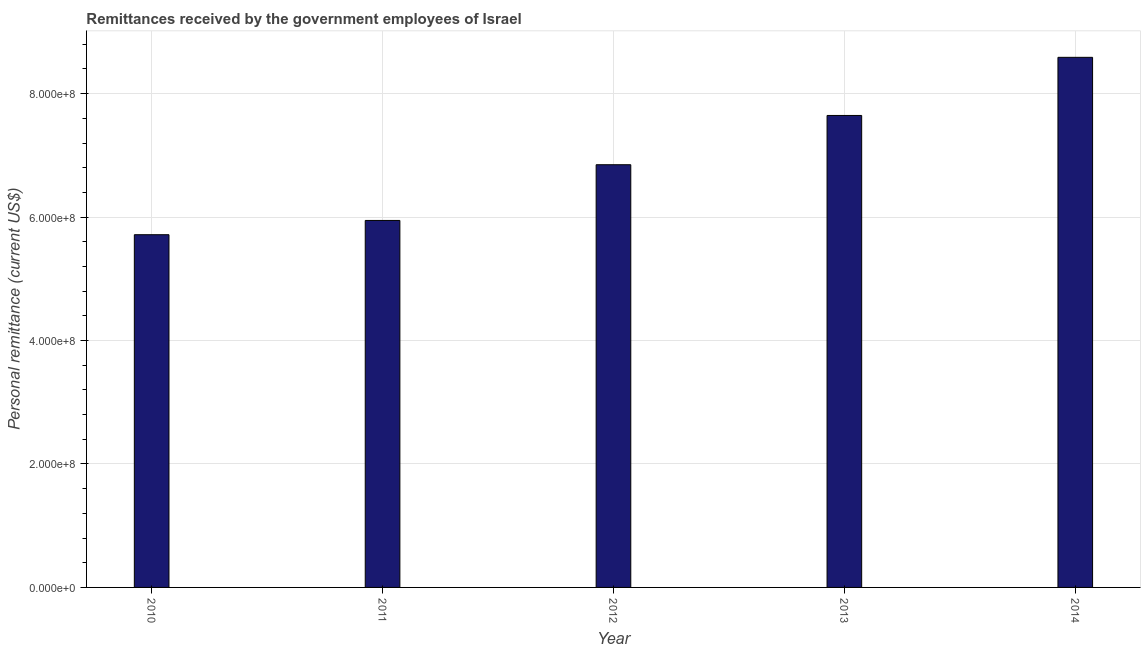Does the graph contain any zero values?
Make the answer very short. No. What is the title of the graph?
Ensure brevity in your answer.  Remittances received by the government employees of Israel. What is the label or title of the X-axis?
Your answer should be compact. Year. What is the label or title of the Y-axis?
Your answer should be very brief. Personal remittance (current US$). What is the personal remittances in 2010?
Make the answer very short. 5.72e+08. Across all years, what is the maximum personal remittances?
Offer a terse response. 8.59e+08. Across all years, what is the minimum personal remittances?
Keep it short and to the point. 5.72e+08. In which year was the personal remittances maximum?
Make the answer very short. 2014. What is the sum of the personal remittances?
Your answer should be very brief. 3.47e+09. What is the difference between the personal remittances in 2011 and 2012?
Give a very brief answer. -9.03e+07. What is the average personal remittances per year?
Provide a short and direct response. 6.95e+08. What is the median personal remittances?
Make the answer very short. 6.85e+08. Do a majority of the years between 2010 and 2012 (inclusive) have personal remittances greater than 240000000 US$?
Ensure brevity in your answer.  Yes. What is the ratio of the personal remittances in 2013 to that in 2014?
Ensure brevity in your answer.  0.89. What is the difference between the highest and the second highest personal remittances?
Make the answer very short. 9.42e+07. What is the difference between the highest and the lowest personal remittances?
Offer a terse response. 2.87e+08. Are all the bars in the graph horizontal?
Make the answer very short. No. Are the values on the major ticks of Y-axis written in scientific E-notation?
Offer a very short reply. Yes. What is the Personal remittance (current US$) of 2010?
Your answer should be compact. 5.72e+08. What is the Personal remittance (current US$) in 2011?
Provide a succinct answer. 5.95e+08. What is the Personal remittance (current US$) of 2012?
Make the answer very short. 6.85e+08. What is the Personal remittance (current US$) in 2013?
Provide a succinct answer. 7.65e+08. What is the Personal remittance (current US$) in 2014?
Provide a succinct answer. 8.59e+08. What is the difference between the Personal remittance (current US$) in 2010 and 2011?
Give a very brief answer. -2.31e+07. What is the difference between the Personal remittance (current US$) in 2010 and 2012?
Keep it short and to the point. -1.13e+08. What is the difference between the Personal remittance (current US$) in 2010 and 2013?
Keep it short and to the point. -1.93e+08. What is the difference between the Personal remittance (current US$) in 2010 and 2014?
Make the answer very short. -2.87e+08. What is the difference between the Personal remittance (current US$) in 2011 and 2012?
Provide a succinct answer. -9.03e+07. What is the difference between the Personal remittance (current US$) in 2011 and 2013?
Give a very brief answer. -1.70e+08. What is the difference between the Personal remittance (current US$) in 2011 and 2014?
Keep it short and to the point. -2.64e+08. What is the difference between the Personal remittance (current US$) in 2012 and 2013?
Keep it short and to the point. -7.98e+07. What is the difference between the Personal remittance (current US$) in 2012 and 2014?
Your answer should be very brief. -1.74e+08. What is the difference between the Personal remittance (current US$) in 2013 and 2014?
Your response must be concise. -9.42e+07. What is the ratio of the Personal remittance (current US$) in 2010 to that in 2011?
Your response must be concise. 0.96. What is the ratio of the Personal remittance (current US$) in 2010 to that in 2012?
Provide a short and direct response. 0.83. What is the ratio of the Personal remittance (current US$) in 2010 to that in 2013?
Your answer should be very brief. 0.75. What is the ratio of the Personal remittance (current US$) in 2010 to that in 2014?
Give a very brief answer. 0.67. What is the ratio of the Personal remittance (current US$) in 2011 to that in 2012?
Offer a terse response. 0.87. What is the ratio of the Personal remittance (current US$) in 2011 to that in 2013?
Give a very brief answer. 0.78. What is the ratio of the Personal remittance (current US$) in 2011 to that in 2014?
Provide a succinct answer. 0.69. What is the ratio of the Personal remittance (current US$) in 2012 to that in 2013?
Offer a terse response. 0.9. What is the ratio of the Personal remittance (current US$) in 2012 to that in 2014?
Make the answer very short. 0.8. What is the ratio of the Personal remittance (current US$) in 2013 to that in 2014?
Your answer should be very brief. 0.89. 